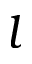<formula> <loc_0><loc_0><loc_500><loc_500>l</formula> 